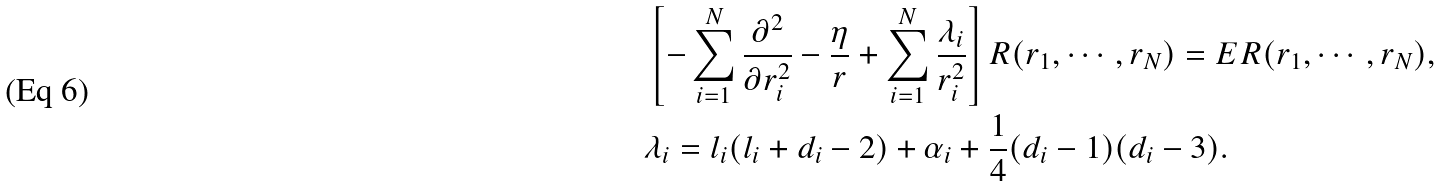<formula> <loc_0><loc_0><loc_500><loc_500>& \left [ - \sum _ { i = 1 } ^ { N } \frac { \partial ^ { 2 } } { \partial r _ { i } ^ { 2 } } - \frac { \eta } { r } + \sum _ { i = 1 } ^ { N } \frac { \lambda _ { i } } { r _ { i } ^ { 2 } } \right ] R ( r _ { 1 } , \cdots , r _ { N } ) = E R ( r _ { 1 } , \cdots , r _ { N } ) , \\ & \lambda _ { i } = l _ { i } ( l _ { i } + d _ { i } - 2 ) + \alpha _ { i } + \frac { 1 } { 4 } ( d _ { i } - 1 ) ( d _ { i } - 3 ) .</formula> 